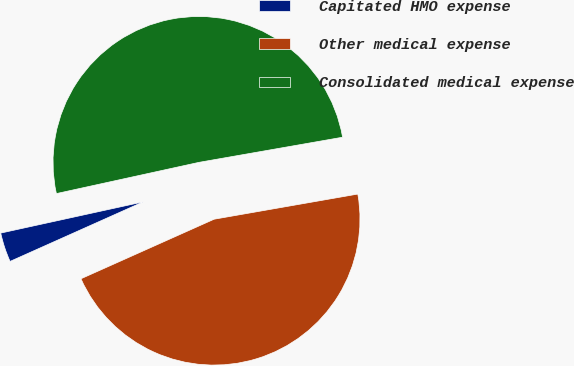<chart> <loc_0><loc_0><loc_500><loc_500><pie_chart><fcel>Capitated HMO expense<fcel>Other medical expense<fcel>Consolidated medical expense<nl><fcel>3.26%<fcel>46.07%<fcel>50.68%<nl></chart> 